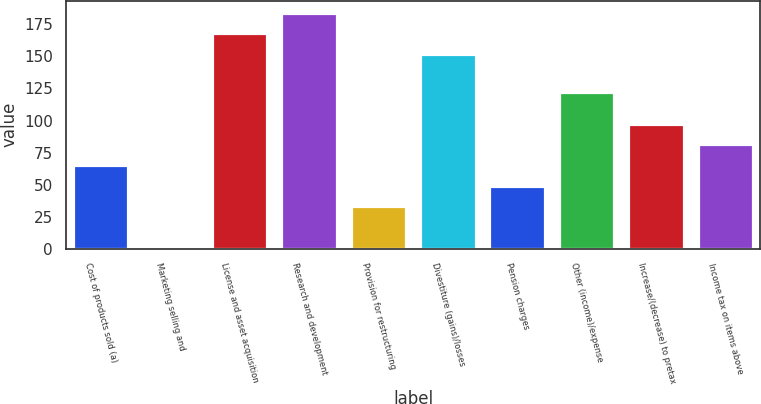<chart> <loc_0><loc_0><loc_500><loc_500><bar_chart><fcel>Cost of products sold (a)<fcel>Marketing selling and<fcel>License and asset acquisition<fcel>Research and development<fcel>Provision for restructuring<fcel>Divestiture (gains)/losses<fcel>Pension charges<fcel>Other (income)/expense<fcel>Increase/(decrease) to pretax<fcel>Income tax on items above<nl><fcel>65.4<fcel>1<fcel>168.1<fcel>184.2<fcel>33.2<fcel>152<fcel>49.3<fcel>122<fcel>97.6<fcel>81.5<nl></chart> 